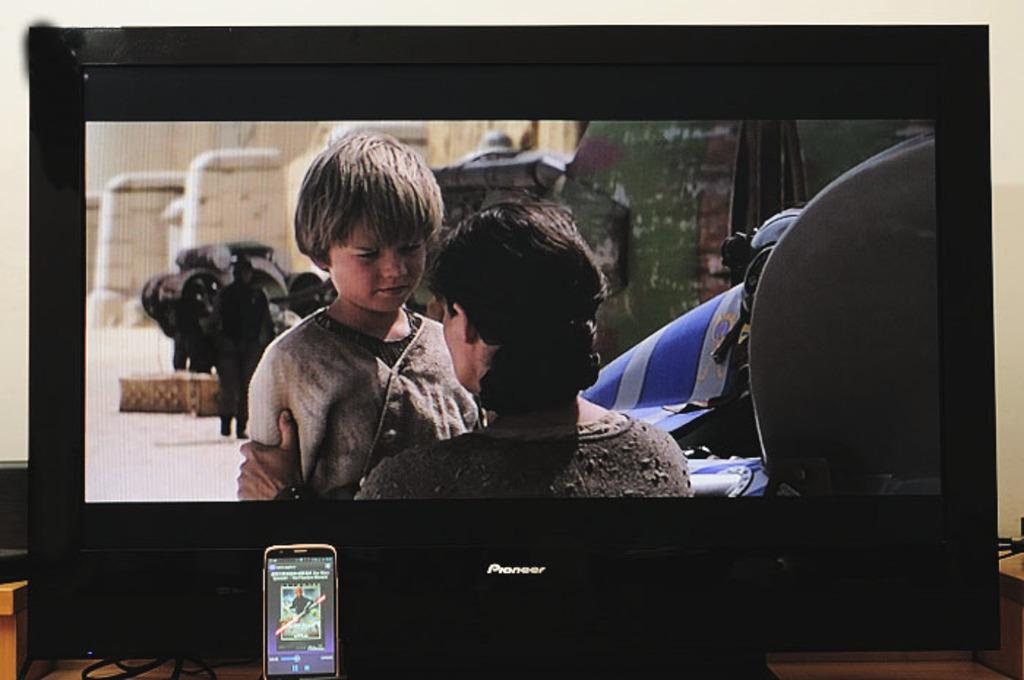What electronic device can be seen in the image? There is a television in the image. What other electronic device is present in the image? There is a mobile phone in the image. Where are the television and mobile phone located? Both the television and the mobile phone are placed on a table. Can you describe the wooden object in the image? There is a wooden object at the bottom left side of the image. What type of donkey is sitting next to the television in the image? There is no donkey present in the image. What does the daughter desire in the image? There is no mention of a daughter or any desires in the image. 